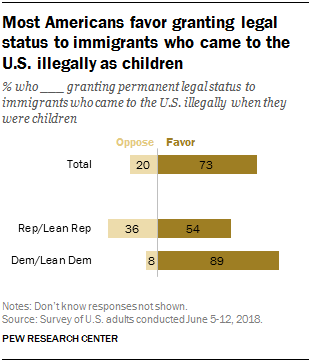Indicate a few pertinent items in this graphic. In the Dem/Lean Dem category, there are 11.12 times more instances where Favor has a higher rating than the opposing team. The values for Rep/Lean Rep shown in the chart are 36 and 54. I oppose the values with 36 and favor the values with 54. 